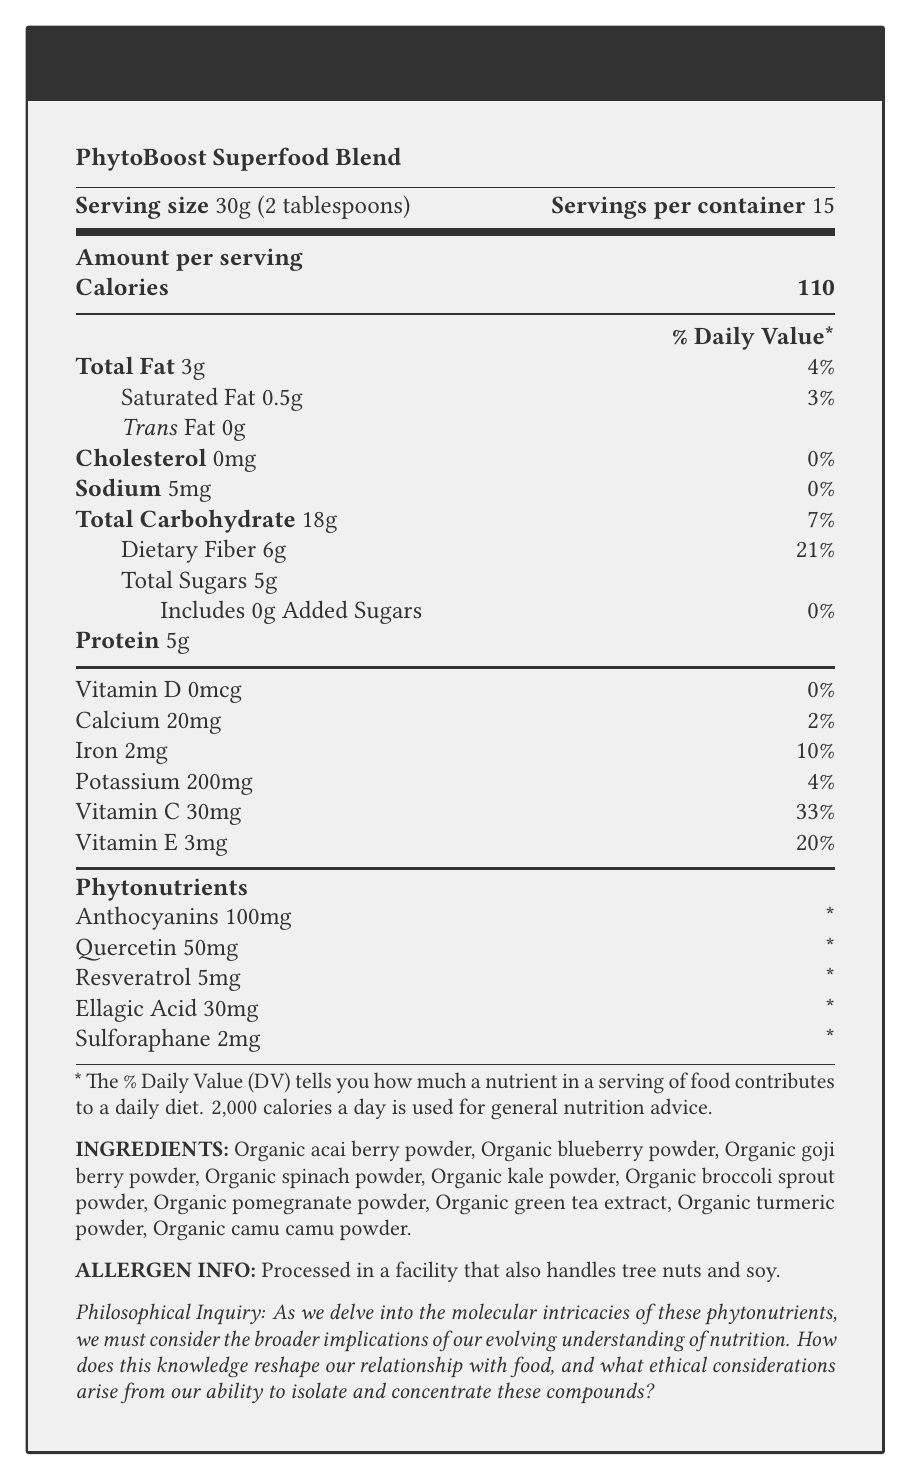What is the serving size of PhytoBoost Superfood Blend? The serving size is clearly listed as 30g (2 tablespoons).
Answer: 30g (2 tablespoons) How many calories are in one serving of PhytoBoost Superfood Blend? The document specifies that there are 110 calories per serving.
Answer: 110 calories What is the total carbohydrate content in one serving? The document lists total carbohydrates as 18g per serving.
Answer: 18g Which phytonutrient is present in the highest amount per serving? Anthocyanins are listed with an amount of 100mg, which is higher than the other phytonutrients listed.
Answer: Anthocyanins What percentage of the daily value is the dietary fiber content? The document specifies that dietary fiber makes up 21% of the daily value per serving.
Answer: 21% Which of the following is NOT an ingredient in PhytoBoost Superfood Blend? 
i. Organic spinach powder 
ii. Organic almond powder 
iii. Organic blueberry powder
iv. Organic turmeric powder The document lists Organic spinach powder, Organic blueberry powder, and Organic turmeric powder as ingredients, but not Organic almond powder.
Answer: ii. Organic almond powder How much Vitamin C is there in one serving? The document lists the Vitamin C content as 30mg per serving.
Answer: 30mg Is there any cholesterol in PhytoBoost Superfood Blend? The document states that cholesterol content is 0mg.
Answer: No Which of the following phytonutrients is present in the lowest amount per serving? 
A. Resveratrol 
B. Ellagic Acid 
C. Quercetin 
D. Sulforaphane Sulforaphane is listed with an amount of 2mg, which is the lowest among the options.
Answer: D. Sulforaphane What is the philosophical inquiry posed in the document? The document ends with a philosophical inquiry about the broader implications of our understanding of phytonutrients.
Answer: How does this knowledge reshape our relationship with food, and what ethical considerations arise from our ability to isolate and concentrate these compounds? What is the protein content per serving? The document states that there are 5g of protein per serving.
Answer: 5g Is there any information about allergens in the PhytoBoost Superfood Blend? The document indicates that the product is processed in a facility that also handles tree nuts and soy.
Answer: Yes Does PhytoBoost Superfood Blend contain any added sugars? The document specifies that there are 0g of added sugars.
Answer: No Summarize the main idea of the Nutrition Facts Label for PhytoBoost Superfood Blend. The summary covers the major elements including nutrient content, key ingredients, and additional information relevant to consumers.
Answer: PhytoBoost Superfood Blend is a nutrient-dense, antioxidant-rich superfood blend containing various vitamins, minerals, and phytonutrients. Each serving size is 30 grams with 110 calories. It is mainly composed of organic fruit and vegetable powders. Key nutrients include dietary fiber, protein, Vitamin C, and Vitamin E. The label also highlights specific phytonutrients like Anthocyanins, Quercetin, and Resveratrol, but their daily values are not established. The product is processed in a facility that handles tree nuts and soy. What is the purpose of including the disclaimer about the daily value percentages? The document includes a disclaimer to clarify that Percent Daily Values listed are based on a 2,000 calorie diet, providing context for nutritional information.
Answer: To inform that Percent Daily Values are based on a 2,000 calorie diet. How much calcium does one serving contain? The document specifies the calcium content as 20mg per serving.
Answer: 20mg What are the health benefits linked to Anthocyanins according to the scientific notes? The scientific notes indicate that Anthocyanins are flavonoids with potent antioxidant properties, extensively studied for their potential neuroprotective effects.
Answer: Potential neuroprotective effects Which nutrient has the highest percent daily value in one serving of PhytoBoost Superfood Blend? The document lists Vitamin C with a 33% daily value per serving, which is the highest percentage among the nutrients listed.
Answer: Vitamin C How do the scientific notes describe the effects of Sulforaphane? According to the scientific notes, Sulforaphane has been the subject of research into its potential chemopreventive properties.
Answer: Potential chemopreventive properties What is the total fat content per serving? The document specifies the total fat content as 3g per serving.
Answer: 3g Is Resveratrol's daily value percentage established? The document indicates that the daily value percentage for Resveratrol is not established.
Answer: No 